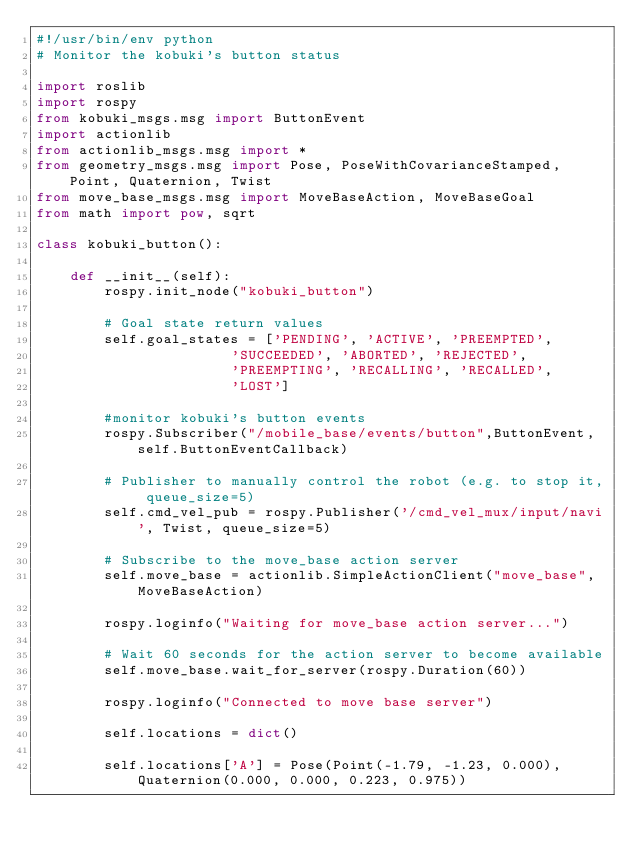<code> <loc_0><loc_0><loc_500><loc_500><_Python_>#!/usr/bin/env python 
# Monitor the kobuki's button status

import roslib
import rospy
from kobuki_msgs.msg import ButtonEvent
import actionlib
from actionlib_msgs.msg import *
from geometry_msgs.msg import Pose, PoseWithCovarianceStamped, Point, Quaternion, Twist
from move_base_msgs.msg import MoveBaseAction, MoveBaseGoal
from math import pow, sqrt

class kobuki_button():

    def __init__(self):
        rospy.init_node("kobuki_button")    

        # Goal state return values
        self.goal_states = ['PENDING', 'ACTIVE', 'PREEMPTED', 
                       'SUCCEEDED', 'ABORTED', 'REJECTED',
                       'PREEMPTING', 'RECALLING', 'RECALLED',
                       'LOST']      

        #monitor kobuki's button events
        rospy.Subscriber("/mobile_base/events/button",ButtonEvent,self.ButtonEventCallback)
        
        # Publisher to manually control the robot (e.g. to stop it, queue_size=5)
        self.cmd_vel_pub = rospy.Publisher('/cmd_vel_mux/input/navi', Twist, queue_size=5)
        
        # Subscribe to the move_base action server
        self.move_base = actionlib.SimpleActionClient("move_base", MoveBaseAction)
        
        rospy.loginfo("Waiting for move_base action server...")
        
        # Wait 60 seconds for the action server to become available
        self.move_base.wait_for_server(rospy.Duration(60))
        
        rospy.loginfo("Connected to move base server")  

        self.locations = dict()
        
        self.locations['A'] = Pose(Point(-1.79, -1.23, 0.000), Quaternion(0.000, 0.000, 0.223, 0.975))</code> 